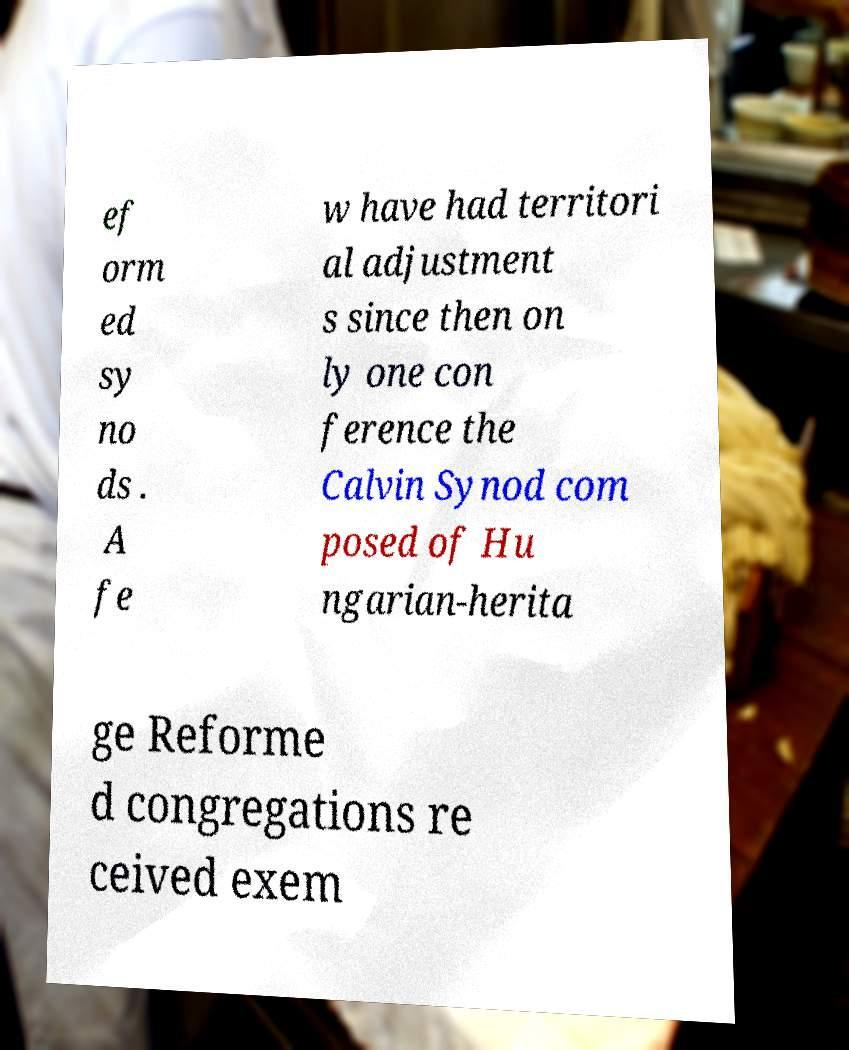Can you accurately transcribe the text from the provided image for me? ef orm ed sy no ds . A fe w have had territori al adjustment s since then on ly one con ference the Calvin Synod com posed of Hu ngarian-herita ge Reforme d congregations re ceived exem 